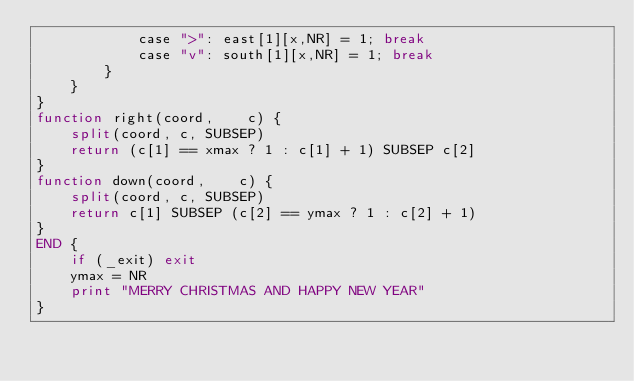Convert code to text. <code><loc_0><loc_0><loc_500><loc_500><_Awk_>            case ">": east[1][x,NR] = 1; break
            case "v": south[1][x,NR] = 1; break
        }
    }
}
function right(coord,    c) {
    split(coord, c, SUBSEP)
    return (c[1] == xmax ? 1 : c[1] + 1) SUBSEP c[2]
}
function down(coord,    c) {
    split(coord, c, SUBSEP)
    return c[1] SUBSEP (c[2] == ymax ? 1 : c[2] + 1)
}
END {
    if (_exit) exit
    ymax = NR
    print "MERRY CHRISTMAS AND HAPPY NEW YEAR"
}
</code> 